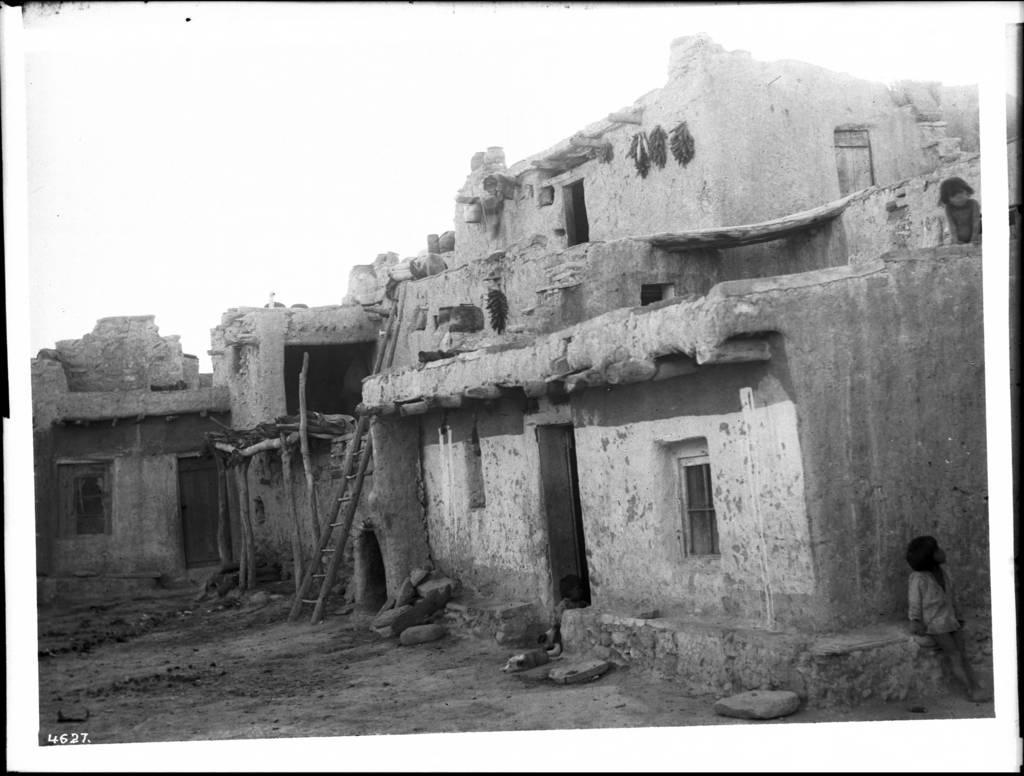Describe this image in one or two sentences. In this image I can see the buildings, windows, doors, ladder, few people and the sky. The image is in black and white. 